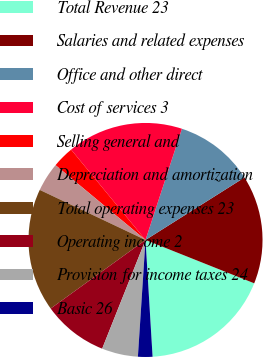<chart> <loc_0><loc_0><loc_500><loc_500><pie_chart><fcel>Total Revenue 23<fcel>Salaries and related expenses<fcel>Office and other direct<fcel>Cost of services 3<fcel>Selling general and<fcel>Depreciation and amortization<fcel>Total operating expenses 23<fcel>Operating income 2<fcel>Provision for income taxes 24<fcel>Basic 26<nl><fcel>18.0%<fcel>15.0%<fcel>11.0%<fcel>16.0%<fcel>3.0%<fcel>4.0%<fcel>17.0%<fcel>9.0%<fcel>5.0%<fcel>2.0%<nl></chart> 